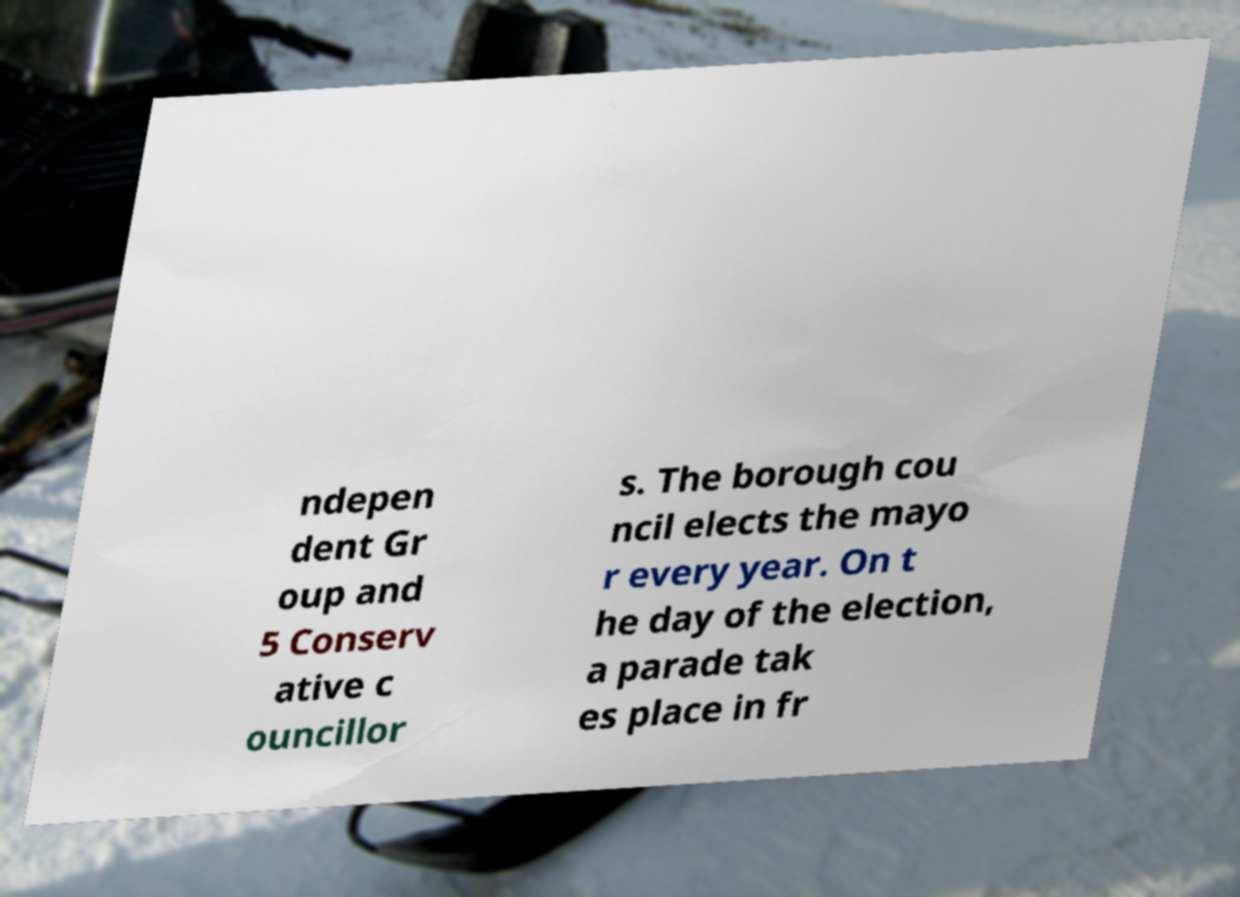I need the written content from this picture converted into text. Can you do that? ndepen dent Gr oup and 5 Conserv ative c ouncillor s. The borough cou ncil elects the mayo r every year. On t he day of the election, a parade tak es place in fr 